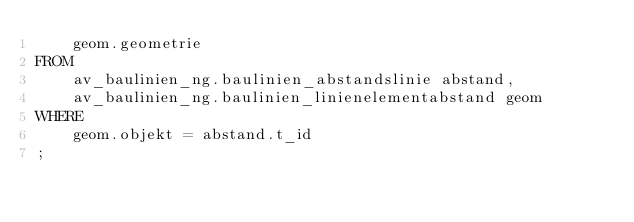Convert code to text. <code><loc_0><loc_0><loc_500><loc_500><_SQL_>    geom.geometrie
FROM 
    av_baulinien_ng.baulinien_abstandslinie abstand, 
    av_baulinien_ng.baulinien_linienelementabstand geom
WHERE 
    geom.objekt = abstand.t_id
;</code> 